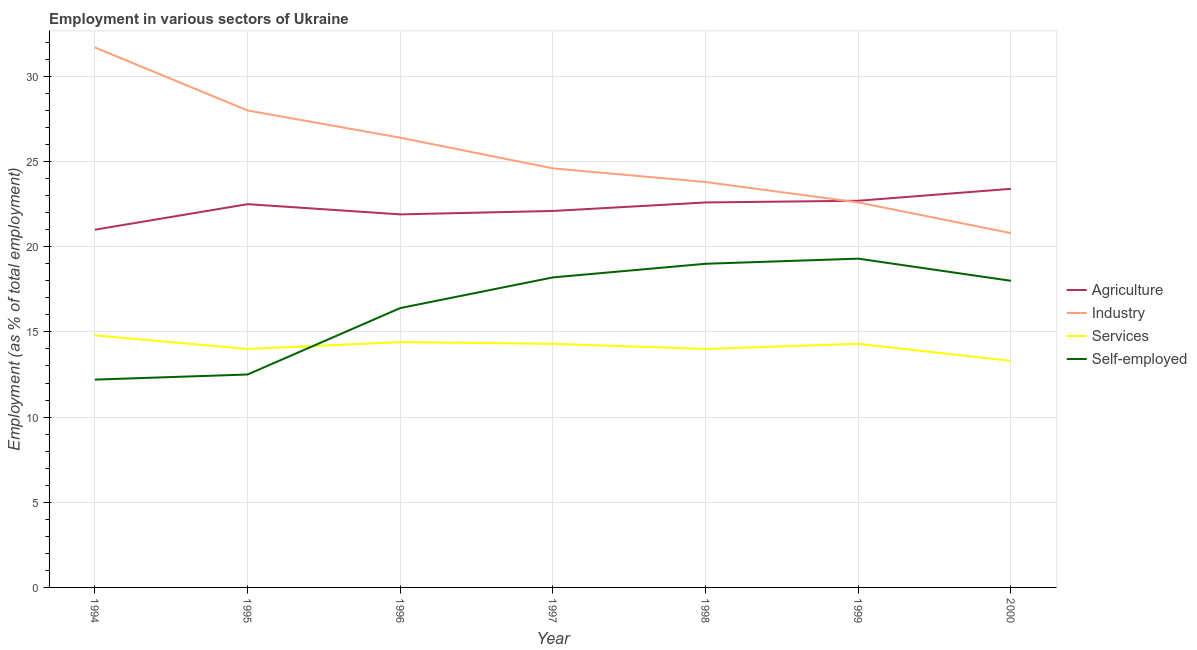Does the line corresponding to percentage of self employed workers intersect with the line corresponding to percentage of workers in industry?
Offer a terse response. No. Is the number of lines equal to the number of legend labels?
Provide a succinct answer. Yes. Across all years, what is the maximum percentage of self employed workers?
Your response must be concise. 19.3. Across all years, what is the minimum percentage of workers in services?
Your answer should be compact. 13.3. In which year was the percentage of self employed workers maximum?
Offer a terse response. 1999. In which year was the percentage of workers in agriculture minimum?
Make the answer very short. 1994. What is the total percentage of workers in industry in the graph?
Offer a very short reply. 177.9. What is the difference between the percentage of workers in services in 1994 and that in 1999?
Provide a succinct answer. 0.5. What is the difference between the percentage of workers in agriculture in 1997 and the percentage of workers in industry in 1994?
Make the answer very short. -9.6. What is the average percentage of workers in services per year?
Give a very brief answer. 14.16. In the year 1998, what is the difference between the percentage of workers in services and percentage of workers in industry?
Give a very brief answer. -9.8. In how many years, is the percentage of workers in agriculture greater than 17 %?
Your response must be concise. 7. What is the ratio of the percentage of workers in industry in 1994 to that in 1996?
Make the answer very short. 1.2. What is the difference between the highest and the second highest percentage of workers in agriculture?
Keep it short and to the point. 0.7. What is the difference between the highest and the lowest percentage of workers in industry?
Keep it short and to the point. 10.9. In how many years, is the percentage of workers in industry greater than the average percentage of workers in industry taken over all years?
Offer a very short reply. 3. How many lines are there?
Give a very brief answer. 4. What is the difference between two consecutive major ticks on the Y-axis?
Provide a succinct answer. 5. Does the graph contain grids?
Provide a succinct answer. Yes. How many legend labels are there?
Make the answer very short. 4. How are the legend labels stacked?
Offer a terse response. Vertical. What is the title of the graph?
Keep it short and to the point. Employment in various sectors of Ukraine. Does "Forest" appear as one of the legend labels in the graph?
Offer a terse response. No. What is the label or title of the X-axis?
Ensure brevity in your answer.  Year. What is the label or title of the Y-axis?
Offer a terse response. Employment (as % of total employment). What is the Employment (as % of total employment) in Agriculture in 1994?
Your answer should be compact. 21. What is the Employment (as % of total employment) in Industry in 1994?
Your response must be concise. 31.7. What is the Employment (as % of total employment) in Services in 1994?
Make the answer very short. 14.8. What is the Employment (as % of total employment) of Self-employed in 1994?
Keep it short and to the point. 12.2. What is the Employment (as % of total employment) in Agriculture in 1996?
Offer a very short reply. 21.9. What is the Employment (as % of total employment) of Industry in 1996?
Give a very brief answer. 26.4. What is the Employment (as % of total employment) in Services in 1996?
Your response must be concise. 14.4. What is the Employment (as % of total employment) of Self-employed in 1996?
Make the answer very short. 16.4. What is the Employment (as % of total employment) of Agriculture in 1997?
Your response must be concise. 22.1. What is the Employment (as % of total employment) of Industry in 1997?
Keep it short and to the point. 24.6. What is the Employment (as % of total employment) in Services in 1997?
Make the answer very short. 14.3. What is the Employment (as % of total employment) in Self-employed in 1997?
Your response must be concise. 18.2. What is the Employment (as % of total employment) of Agriculture in 1998?
Give a very brief answer. 22.6. What is the Employment (as % of total employment) in Industry in 1998?
Provide a short and direct response. 23.8. What is the Employment (as % of total employment) in Agriculture in 1999?
Your answer should be compact. 22.7. What is the Employment (as % of total employment) of Industry in 1999?
Provide a succinct answer. 22.6. What is the Employment (as % of total employment) in Services in 1999?
Give a very brief answer. 14.3. What is the Employment (as % of total employment) of Self-employed in 1999?
Make the answer very short. 19.3. What is the Employment (as % of total employment) in Agriculture in 2000?
Your answer should be very brief. 23.4. What is the Employment (as % of total employment) of Industry in 2000?
Your answer should be very brief. 20.8. What is the Employment (as % of total employment) in Services in 2000?
Your answer should be very brief. 13.3. Across all years, what is the maximum Employment (as % of total employment) of Agriculture?
Provide a short and direct response. 23.4. Across all years, what is the maximum Employment (as % of total employment) in Industry?
Ensure brevity in your answer.  31.7. Across all years, what is the maximum Employment (as % of total employment) of Services?
Ensure brevity in your answer.  14.8. Across all years, what is the maximum Employment (as % of total employment) in Self-employed?
Give a very brief answer. 19.3. Across all years, what is the minimum Employment (as % of total employment) of Agriculture?
Keep it short and to the point. 21. Across all years, what is the minimum Employment (as % of total employment) in Industry?
Give a very brief answer. 20.8. Across all years, what is the minimum Employment (as % of total employment) in Services?
Ensure brevity in your answer.  13.3. Across all years, what is the minimum Employment (as % of total employment) in Self-employed?
Give a very brief answer. 12.2. What is the total Employment (as % of total employment) in Agriculture in the graph?
Ensure brevity in your answer.  156.2. What is the total Employment (as % of total employment) of Industry in the graph?
Your answer should be compact. 177.9. What is the total Employment (as % of total employment) of Services in the graph?
Ensure brevity in your answer.  99.1. What is the total Employment (as % of total employment) of Self-employed in the graph?
Give a very brief answer. 115.6. What is the difference between the Employment (as % of total employment) of Agriculture in 1994 and that in 1995?
Offer a very short reply. -1.5. What is the difference between the Employment (as % of total employment) in Industry in 1994 and that in 1995?
Provide a short and direct response. 3.7. What is the difference between the Employment (as % of total employment) of Services in 1994 and that in 1995?
Your answer should be compact. 0.8. What is the difference between the Employment (as % of total employment) in Self-employed in 1994 and that in 1996?
Give a very brief answer. -4.2. What is the difference between the Employment (as % of total employment) of Agriculture in 1994 and that in 1997?
Provide a succinct answer. -1.1. What is the difference between the Employment (as % of total employment) in Services in 1994 and that in 1998?
Provide a succinct answer. 0.8. What is the difference between the Employment (as % of total employment) of Self-employed in 1994 and that in 1998?
Provide a short and direct response. -6.8. What is the difference between the Employment (as % of total employment) of Industry in 1994 and that in 1999?
Ensure brevity in your answer.  9.1. What is the difference between the Employment (as % of total employment) of Services in 1994 and that in 1999?
Make the answer very short. 0.5. What is the difference between the Employment (as % of total employment) of Self-employed in 1994 and that in 2000?
Offer a very short reply. -5.8. What is the difference between the Employment (as % of total employment) of Services in 1995 and that in 1996?
Your answer should be compact. -0.4. What is the difference between the Employment (as % of total employment) in Agriculture in 1995 and that in 1997?
Keep it short and to the point. 0.4. What is the difference between the Employment (as % of total employment) of Self-employed in 1995 and that in 1997?
Offer a terse response. -5.7. What is the difference between the Employment (as % of total employment) in Agriculture in 1995 and that in 1998?
Keep it short and to the point. -0.1. What is the difference between the Employment (as % of total employment) in Self-employed in 1995 and that in 1998?
Ensure brevity in your answer.  -6.5. What is the difference between the Employment (as % of total employment) of Industry in 1995 and that in 2000?
Make the answer very short. 7.2. What is the difference between the Employment (as % of total employment) of Services in 1995 and that in 2000?
Ensure brevity in your answer.  0.7. What is the difference between the Employment (as % of total employment) of Self-employed in 1995 and that in 2000?
Keep it short and to the point. -5.5. What is the difference between the Employment (as % of total employment) of Agriculture in 1996 and that in 1997?
Your response must be concise. -0.2. What is the difference between the Employment (as % of total employment) in Industry in 1996 and that in 1998?
Keep it short and to the point. 2.6. What is the difference between the Employment (as % of total employment) of Self-employed in 1996 and that in 1998?
Keep it short and to the point. -2.6. What is the difference between the Employment (as % of total employment) in Industry in 1996 and that in 1999?
Ensure brevity in your answer.  3.8. What is the difference between the Employment (as % of total employment) in Agriculture in 1996 and that in 2000?
Your answer should be very brief. -1.5. What is the difference between the Employment (as % of total employment) in Industry in 1996 and that in 2000?
Ensure brevity in your answer.  5.6. What is the difference between the Employment (as % of total employment) of Self-employed in 1996 and that in 2000?
Your response must be concise. -1.6. What is the difference between the Employment (as % of total employment) of Agriculture in 1997 and that in 1999?
Your answer should be compact. -0.6. What is the difference between the Employment (as % of total employment) of Industry in 1997 and that in 1999?
Offer a terse response. 2. What is the difference between the Employment (as % of total employment) of Services in 1997 and that in 1999?
Give a very brief answer. 0. What is the difference between the Employment (as % of total employment) of Self-employed in 1997 and that in 1999?
Give a very brief answer. -1.1. What is the difference between the Employment (as % of total employment) in Services in 1997 and that in 2000?
Make the answer very short. 1. What is the difference between the Employment (as % of total employment) in Self-employed in 1997 and that in 2000?
Make the answer very short. 0.2. What is the difference between the Employment (as % of total employment) of Agriculture in 1998 and that in 1999?
Your response must be concise. -0.1. What is the difference between the Employment (as % of total employment) of Industry in 1998 and that in 1999?
Your answer should be compact. 1.2. What is the difference between the Employment (as % of total employment) in Services in 1998 and that in 1999?
Offer a very short reply. -0.3. What is the difference between the Employment (as % of total employment) of Self-employed in 1998 and that in 1999?
Your answer should be very brief. -0.3. What is the difference between the Employment (as % of total employment) in Agriculture in 1998 and that in 2000?
Your answer should be very brief. -0.8. What is the difference between the Employment (as % of total employment) of Industry in 1998 and that in 2000?
Your answer should be compact. 3. What is the difference between the Employment (as % of total employment) in Services in 1998 and that in 2000?
Offer a terse response. 0.7. What is the difference between the Employment (as % of total employment) in Agriculture in 1999 and that in 2000?
Provide a short and direct response. -0.7. What is the difference between the Employment (as % of total employment) of Services in 1999 and that in 2000?
Provide a succinct answer. 1. What is the difference between the Employment (as % of total employment) in Agriculture in 1994 and the Employment (as % of total employment) in Self-employed in 1995?
Provide a short and direct response. 8.5. What is the difference between the Employment (as % of total employment) of Industry in 1994 and the Employment (as % of total employment) of Self-employed in 1995?
Your response must be concise. 19.2. What is the difference between the Employment (as % of total employment) in Services in 1994 and the Employment (as % of total employment) in Self-employed in 1995?
Your response must be concise. 2.3. What is the difference between the Employment (as % of total employment) of Agriculture in 1994 and the Employment (as % of total employment) of Industry in 1996?
Your response must be concise. -5.4. What is the difference between the Employment (as % of total employment) in Agriculture in 1994 and the Employment (as % of total employment) in Services in 1996?
Your response must be concise. 6.6. What is the difference between the Employment (as % of total employment) in Agriculture in 1994 and the Employment (as % of total employment) in Self-employed in 1996?
Provide a short and direct response. 4.6. What is the difference between the Employment (as % of total employment) of Industry in 1994 and the Employment (as % of total employment) of Services in 1996?
Provide a succinct answer. 17.3. What is the difference between the Employment (as % of total employment) in Industry in 1994 and the Employment (as % of total employment) in Self-employed in 1996?
Your answer should be very brief. 15.3. What is the difference between the Employment (as % of total employment) of Services in 1994 and the Employment (as % of total employment) of Self-employed in 1996?
Ensure brevity in your answer.  -1.6. What is the difference between the Employment (as % of total employment) in Agriculture in 1994 and the Employment (as % of total employment) in Self-employed in 1997?
Make the answer very short. 2.8. What is the difference between the Employment (as % of total employment) in Agriculture in 1994 and the Employment (as % of total employment) in Services in 1998?
Give a very brief answer. 7. What is the difference between the Employment (as % of total employment) in Industry in 1994 and the Employment (as % of total employment) in Self-employed in 1998?
Provide a short and direct response. 12.7. What is the difference between the Employment (as % of total employment) of Agriculture in 1994 and the Employment (as % of total employment) of Industry in 1999?
Ensure brevity in your answer.  -1.6. What is the difference between the Employment (as % of total employment) of Services in 1994 and the Employment (as % of total employment) of Self-employed in 1999?
Offer a very short reply. -4.5. What is the difference between the Employment (as % of total employment) in Agriculture in 1994 and the Employment (as % of total employment) in Industry in 2000?
Offer a very short reply. 0.2. What is the difference between the Employment (as % of total employment) of Industry in 1994 and the Employment (as % of total employment) of Services in 2000?
Keep it short and to the point. 18.4. What is the difference between the Employment (as % of total employment) in Industry in 1994 and the Employment (as % of total employment) in Self-employed in 2000?
Your answer should be very brief. 13.7. What is the difference between the Employment (as % of total employment) of Services in 1994 and the Employment (as % of total employment) of Self-employed in 2000?
Your answer should be very brief. -3.2. What is the difference between the Employment (as % of total employment) of Agriculture in 1995 and the Employment (as % of total employment) of Industry in 1996?
Your answer should be compact. -3.9. What is the difference between the Employment (as % of total employment) of Agriculture in 1995 and the Employment (as % of total employment) of Services in 1996?
Keep it short and to the point. 8.1. What is the difference between the Employment (as % of total employment) in Agriculture in 1995 and the Employment (as % of total employment) in Self-employed in 1996?
Provide a succinct answer. 6.1. What is the difference between the Employment (as % of total employment) in Industry in 1995 and the Employment (as % of total employment) in Self-employed in 1996?
Give a very brief answer. 11.6. What is the difference between the Employment (as % of total employment) of Agriculture in 1995 and the Employment (as % of total employment) of Industry in 1997?
Your answer should be compact. -2.1. What is the difference between the Employment (as % of total employment) of Agriculture in 1995 and the Employment (as % of total employment) of Self-employed in 1997?
Provide a short and direct response. 4.3. What is the difference between the Employment (as % of total employment) in Industry in 1995 and the Employment (as % of total employment) in Self-employed in 1997?
Provide a succinct answer. 9.8. What is the difference between the Employment (as % of total employment) of Industry in 1995 and the Employment (as % of total employment) of Services in 1998?
Your answer should be compact. 14. What is the difference between the Employment (as % of total employment) of Industry in 1995 and the Employment (as % of total employment) of Self-employed in 1998?
Provide a short and direct response. 9. What is the difference between the Employment (as % of total employment) of Services in 1995 and the Employment (as % of total employment) of Self-employed in 1998?
Offer a very short reply. -5. What is the difference between the Employment (as % of total employment) of Services in 1995 and the Employment (as % of total employment) of Self-employed in 1999?
Keep it short and to the point. -5.3. What is the difference between the Employment (as % of total employment) of Agriculture in 1995 and the Employment (as % of total employment) of Services in 2000?
Offer a very short reply. 9.2. What is the difference between the Employment (as % of total employment) of Industry in 1995 and the Employment (as % of total employment) of Services in 2000?
Provide a succinct answer. 14.7. What is the difference between the Employment (as % of total employment) in Industry in 1995 and the Employment (as % of total employment) in Self-employed in 2000?
Ensure brevity in your answer.  10. What is the difference between the Employment (as % of total employment) of Agriculture in 1996 and the Employment (as % of total employment) of Services in 1997?
Keep it short and to the point. 7.6. What is the difference between the Employment (as % of total employment) of Agriculture in 1996 and the Employment (as % of total employment) of Industry in 1998?
Your answer should be compact. -1.9. What is the difference between the Employment (as % of total employment) in Industry in 1996 and the Employment (as % of total employment) in Services in 1998?
Give a very brief answer. 12.4. What is the difference between the Employment (as % of total employment) of Industry in 1996 and the Employment (as % of total employment) of Self-employed in 1998?
Offer a very short reply. 7.4. What is the difference between the Employment (as % of total employment) of Agriculture in 1996 and the Employment (as % of total employment) of Industry in 1999?
Make the answer very short. -0.7. What is the difference between the Employment (as % of total employment) of Agriculture in 1996 and the Employment (as % of total employment) of Services in 1999?
Keep it short and to the point. 7.6. What is the difference between the Employment (as % of total employment) in Agriculture in 1996 and the Employment (as % of total employment) in Self-employed in 1999?
Offer a very short reply. 2.6. What is the difference between the Employment (as % of total employment) of Industry in 1996 and the Employment (as % of total employment) of Services in 1999?
Offer a terse response. 12.1. What is the difference between the Employment (as % of total employment) of Agriculture in 1996 and the Employment (as % of total employment) of Industry in 2000?
Provide a short and direct response. 1.1. What is the difference between the Employment (as % of total employment) of Agriculture in 1996 and the Employment (as % of total employment) of Services in 2000?
Give a very brief answer. 8.6. What is the difference between the Employment (as % of total employment) of Agriculture in 1996 and the Employment (as % of total employment) of Self-employed in 2000?
Provide a short and direct response. 3.9. What is the difference between the Employment (as % of total employment) of Agriculture in 1997 and the Employment (as % of total employment) of Services in 1998?
Provide a short and direct response. 8.1. What is the difference between the Employment (as % of total employment) of Agriculture in 1997 and the Employment (as % of total employment) of Self-employed in 1998?
Your response must be concise. 3.1. What is the difference between the Employment (as % of total employment) in Industry in 1997 and the Employment (as % of total employment) in Services in 1998?
Your response must be concise. 10.6. What is the difference between the Employment (as % of total employment) in Services in 1997 and the Employment (as % of total employment) in Self-employed in 1998?
Your answer should be compact. -4.7. What is the difference between the Employment (as % of total employment) of Agriculture in 1997 and the Employment (as % of total employment) of Industry in 1999?
Provide a succinct answer. -0.5. What is the difference between the Employment (as % of total employment) in Services in 1997 and the Employment (as % of total employment) in Self-employed in 1999?
Offer a very short reply. -5. What is the difference between the Employment (as % of total employment) of Agriculture in 1997 and the Employment (as % of total employment) of Industry in 2000?
Ensure brevity in your answer.  1.3. What is the difference between the Employment (as % of total employment) in Agriculture in 1997 and the Employment (as % of total employment) in Self-employed in 2000?
Provide a succinct answer. 4.1. What is the difference between the Employment (as % of total employment) in Services in 1997 and the Employment (as % of total employment) in Self-employed in 2000?
Your response must be concise. -3.7. What is the difference between the Employment (as % of total employment) in Agriculture in 1998 and the Employment (as % of total employment) in Self-employed in 1999?
Ensure brevity in your answer.  3.3. What is the difference between the Employment (as % of total employment) in Industry in 1998 and the Employment (as % of total employment) in Self-employed in 1999?
Your answer should be compact. 4.5. What is the difference between the Employment (as % of total employment) in Agriculture in 1998 and the Employment (as % of total employment) in Industry in 2000?
Ensure brevity in your answer.  1.8. What is the difference between the Employment (as % of total employment) of Agriculture in 1998 and the Employment (as % of total employment) of Self-employed in 2000?
Your answer should be compact. 4.6. What is the difference between the Employment (as % of total employment) of Industry in 1998 and the Employment (as % of total employment) of Services in 2000?
Ensure brevity in your answer.  10.5. What is the difference between the Employment (as % of total employment) in Industry in 1999 and the Employment (as % of total employment) in Services in 2000?
Your answer should be very brief. 9.3. What is the difference between the Employment (as % of total employment) of Industry in 1999 and the Employment (as % of total employment) of Self-employed in 2000?
Provide a short and direct response. 4.6. What is the difference between the Employment (as % of total employment) in Services in 1999 and the Employment (as % of total employment) in Self-employed in 2000?
Offer a very short reply. -3.7. What is the average Employment (as % of total employment) of Agriculture per year?
Make the answer very short. 22.31. What is the average Employment (as % of total employment) in Industry per year?
Your answer should be compact. 25.41. What is the average Employment (as % of total employment) in Services per year?
Your response must be concise. 14.16. What is the average Employment (as % of total employment) in Self-employed per year?
Your answer should be very brief. 16.51. In the year 1994, what is the difference between the Employment (as % of total employment) in Agriculture and Employment (as % of total employment) in Industry?
Offer a terse response. -10.7. In the year 1994, what is the difference between the Employment (as % of total employment) of Industry and Employment (as % of total employment) of Self-employed?
Offer a terse response. 19.5. In the year 1995, what is the difference between the Employment (as % of total employment) of Industry and Employment (as % of total employment) of Services?
Provide a succinct answer. 14. In the year 1995, what is the difference between the Employment (as % of total employment) in Services and Employment (as % of total employment) in Self-employed?
Give a very brief answer. 1.5. In the year 1996, what is the difference between the Employment (as % of total employment) of Agriculture and Employment (as % of total employment) of Industry?
Your answer should be very brief. -4.5. In the year 1997, what is the difference between the Employment (as % of total employment) of Agriculture and Employment (as % of total employment) of Industry?
Give a very brief answer. -2.5. In the year 1997, what is the difference between the Employment (as % of total employment) in Agriculture and Employment (as % of total employment) in Services?
Offer a terse response. 7.8. In the year 1997, what is the difference between the Employment (as % of total employment) of Agriculture and Employment (as % of total employment) of Self-employed?
Your answer should be compact. 3.9. In the year 1997, what is the difference between the Employment (as % of total employment) of Industry and Employment (as % of total employment) of Services?
Give a very brief answer. 10.3. In the year 1998, what is the difference between the Employment (as % of total employment) in Agriculture and Employment (as % of total employment) in Services?
Your response must be concise. 8.6. In the year 1998, what is the difference between the Employment (as % of total employment) in Industry and Employment (as % of total employment) in Services?
Your response must be concise. 9.8. In the year 1998, what is the difference between the Employment (as % of total employment) of Industry and Employment (as % of total employment) of Self-employed?
Make the answer very short. 4.8. In the year 1998, what is the difference between the Employment (as % of total employment) in Services and Employment (as % of total employment) in Self-employed?
Your answer should be compact. -5. In the year 1999, what is the difference between the Employment (as % of total employment) in Industry and Employment (as % of total employment) in Self-employed?
Provide a short and direct response. 3.3. In the year 1999, what is the difference between the Employment (as % of total employment) of Services and Employment (as % of total employment) of Self-employed?
Provide a short and direct response. -5. In the year 2000, what is the difference between the Employment (as % of total employment) in Agriculture and Employment (as % of total employment) in Industry?
Your response must be concise. 2.6. In the year 2000, what is the difference between the Employment (as % of total employment) of Agriculture and Employment (as % of total employment) of Services?
Provide a succinct answer. 10.1. In the year 2000, what is the difference between the Employment (as % of total employment) in Agriculture and Employment (as % of total employment) in Self-employed?
Offer a terse response. 5.4. In the year 2000, what is the difference between the Employment (as % of total employment) in Industry and Employment (as % of total employment) in Services?
Provide a short and direct response. 7.5. In the year 2000, what is the difference between the Employment (as % of total employment) in Services and Employment (as % of total employment) in Self-employed?
Provide a short and direct response. -4.7. What is the ratio of the Employment (as % of total employment) of Industry in 1994 to that in 1995?
Your answer should be compact. 1.13. What is the ratio of the Employment (as % of total employment) of Services in 1994 to that in 1995?
Offer a very short reply. 1.06. What is the ratio of the Employment (as % of total employment) in Agriculture in 1994 to that in 1996?
Offer a terse response. 0.96. What is the ratio of the Employment (as % of total employment) of Industry in 1994 to that in 1996?
Provide a short and direct response. 1.2. What is the ratio of the Employment (as % of total employment) of Services in 1994 to that in 1996?
Your answer should be compact. 1.03. What is the ratio of the Employment (as % of total employment) in Self-employed in 1994 to that in 1996?
Provide a short and direct response. 0.74. What is the ratio of the Employment (as % of total employment) of Agriculture in 1994 to that in 1997?
Provide a succinct answer. 0.95. What is the ratio of the Employment (as % of total employment) of Industry in 1994 to that in 1997?
Your answer should be compact. 1.29. What is the ratio of the Employment (as % of total employment) of Services in 1994 to that in 1997?
Your response must be concise. 1.03. What is the ratio of the Employment (as % of total employment) in Self-employed in 1994 to that in 1997?
Your response must be concise. 0.67. What is the ratio of the Employment (as % of total employment) in Agriculture in 1994 to that in 1998?
Make the answer very short. 0.93. What is the ratio of the Employment (as % of total employment) in Industry in 1994 to that in 1998?
Offer a very short reply. 1.33. What is the ratio of the Employment (as % of total employment) in Services in 1994 to that in 1998?
Your answer should be very brief. 1.06. What is the ratio of the Employment (as % of total employment) of Self-employed in 1994 to that in 1998?
Your answer should be compact. 0.64. What is the ratio of the Employment (as % of total employment) of Agriculture in 1994 to that in 1999?
Ensure brevity in your answer.  0.93. What is the ratio of the Employment (as % of total employment) of Industry in 1994 to that in 1999?
Offer a terse response. 1.4. What is the ratio of the Employment (as % of total employment) of Services in 1994 to that in 1999?
Make the answer very short. 1.03. What is the ratio of the Employment (as % of total employment) of Self-employed in 1994 to that in 1999?
Your answer should be compact. 0.63. What is the ratio of the Employment (as % of total employment) in Agriculture in 1994 to that in 2000?
Provide a short and direct response. 0.9. What is the ratio of the Employment (as % of total employment) in Industry in 1994 to that in 2000?
Provide a succinct answer. 1.52. What is the ratio of the Employment (as % of total employment) in Services in 1994 to that in 2000?
Your answer should be very brief. 1.11. What is the ratio of the Employment (as % of total employment) of Self-employed in 1994 to that in 2000?
Your response must be concise. 0.68. What is the ratio of the Employment (as % of total employment) of Agriculture in 1995 to that in 1996?
Keep it short and to the point. 1.03. What is the ratio of the Employment (as % of total employment) of Industry in 1995 to that in 1996?
Your answer should be compact. 1.06. What is the ratio of the Employment (as % of total employment) in Services in 1995 to that in 1996?
Offer a very short reply. 0.97. What is the ratio of the Employment (as % of total employment) in Self-employed in 1995 to that in 1996?
Provide a short and direct response. 0.76. What is the ratio of the Employment (as % of total employment) in Agriculture in 1995 to that in 1997?
Keep it short and to the point. 1.02. What is the ratio of the Employment (as % of total employment) in Industry in 1995 to that in 1997?
Provide a succinct answer. 1.14. What is the ratio of the Employment (as % of total employment) of Services in 1995 to that in 1997?
Ensure brevity in your answer.  0.98. What is the ratio of the Employment (as % of total employment) of Self-employed in 1995 to that in 1997?
Offer a terse response. 0.69. What is the ratio of the Employment (as % of total employment) of Industry in 1995 to that in 1998?
Offer a very short reply. 1.18. What is the ratio of the Employment (as % of total employment) of Self-employed in 1995 to that in 1998?
Offer a terse response. 0.66. What is the ratio of the Employment (as % of total employment) in Industry in 1995 to that in 1999?
Offer a very short reply. 1.24. What is the ratio of the Employment (as % of total employment) in Services in 1995 to that in 1999?
Provide a short and direct response. 0.98. What is the ratio of the Employment (as % of total employment) of Self-employed in 1995 to that in 1999?
Offer a very short reply. 0.65. What is the ratio of the Employment (as % of total employment) in Agriculture in 1995 to that in 2000?
Keep it short and to the point. 0.96. What is the ratio of the Employment (as % of total employment) of Industry in 1995 to that in 2000?
Give a very brief answer. 1.35. What is the ratio of the Employment (as % of total employment) of Services in 1995 to that in 2000?
Keep it short and to the point. 1.05. What is the ratio of the Employment (as % of total employment) in Self-employed in 1995 to that in 2000?
Your answer should be very brief. 0.69. What is the ratio of the Employment (as % of total employment) of Industry in 1996 to that in 1997?
Ensure brevity in your answer.  1.07. What is the ratio of the Employment (as % of total employment) in Services in 1996 to that in 1997?
Make the answer very short. 1.01. What is the ratio of the Employment (as % of total employment) in Self-employed in 1996 to that in 1997?
Make the answer very short. 0.9. What is the ratio of the Employment (as % of total employment) in Industry in 1996 to that in 1998?
Offer a terse response. 1.11. What is the ratio of the Employment (as % of total employment) in Services in 1996 to that in 1998?
Provide a short and direct response. 1.03. What is the ratio of the Employment (as % of total employment) in Self-employed in 1996 to that in 1998?
Offer a very short reply. 0.86. What is the ratio of the Employment (as % of total employment) in Agriculture in 1996 to that in 1999?
Your answer should be compact. 0.96. What is the ratio of the Employment (as % of total employment) of Industry in 1996 to that in 1999?
Keep it short and to the point. 1.17. What is the ratio of the Employment (as % of total employment) of Services in 1996 to that in 1999?
Offer a terse response. 1.01. What is the ratio of the Employment (as % of total employment) of Self-employed in 1996 to that in 1999?
Keep it short and to the point. 0.85. What is the ratio of the Employment (as % of total employment) in Agriculture in 1996 to that in 2000?
Provide a short and direct response. 0.94. What is the ratio of the Employment (as % of total employment) of Industry in 1996 to that in 2000?
Your answer should be compact. 1.27. What is the ratio of the Employment (as % of total employment) in Services in 1996 to that in 2000?
Offer a terse response. 1.08. What is the ratio of the Employment (as % of total employment) in Self-employed in 1996 to that in 2000?
Your answer should be compact. 0.91. What is the ratio of the Employment (as % of total employment) in Agriculture in 1997 to that in 1998?
Provide a short and direct response. 0.98. What is the ratio of the Employment (as % of total employment) of Industry in 1997 to that in 1998?
Keep it short and to the point. 1.03. What is the ratio of the Employment (as % of total employment) in Services in 1997 to that in 1998?
Make the answer very short. 1.02. What is the ratio of the Employment (as % of total employment) in Self-employed in 1997 to that in 1998?
Provide a succinct answer. 0.96. What is the ratio of the Employment (as % of total employment) in Agriculture in 1997 to that in 1999?
Keep it short and to the point. 0.97. What is the ratio of the Employment (as % of total employment) of Industry in 1997 to that in 1999?
Give a very brief answer. 1.09. What is the ratio of the Employment (as % of total employment) in Self-employed in 1997 to that in 1999?
Ensure brevity in your answer.  0.94. What is the ratio of the Employment (as % of total employment) of Agriculture in 1997 to that in 2000?
Your response must be concise. 0.94. What is the ratio of the Employment (as % of total employment) of Industry in 1997 to that in 2000?
Ensure brevity in your answer.  1.18. What is the ratio of the Employment (as % of total employment) in Services in 1997 to that in 2000?
Provide a short and direct response. 1.08. What is the ratio of the Employment (as % of total employment) of Self-employed in 1997 to that in 2000?
Keep it short and to the point. 1.01. What is the ratio of the Employment (as % of total employment) of Industry in 1998 to that in 1999?
Provide a succinct answer. 1.05. What is the ratio of the Employment (as % of total employment) in Services in 1998 to that in 1999?
Give a very brief answer. 0.98. What is the ratio of the Employment (as % of total employment) of Self-employed in 1998 to that in 1999?
Make the answer very short. 0.98. What is the ratio of the Employment (as % of total employment) in Agriculture in 1998 to that in 2000?
Give a very brief answer. 0.97. What is the ratio of the Employment (as % of total employment) in Industry in 1998 to that in 2000?
Give a very brief answer. 1.14. What is the ratio of the Employment (as % of total employment) in Services in 1998 to that in 2000?
Offer a terse response. 1.05. What is the ratio of the Employment (as % of total employment) of Self-employed in 1998 to that in 2000?
Offer a very short reply. 1.06. What is the ratio of the Employment (as % of total employment) in Agriculture in 1999 to that in 2000?
Give a very brief answer. 0.97. What is the ratio of the Employment (as % of total employment) in Industry in 1999 to that in 2000?
Ensure brevity in your answer.  1.09. What is the ratio of the Employment (as % of total employment) of Services in 1999 to that in 2000?
Give a very brief answer. 1.08. What is the ratio of the Employment (as % of total employment) in Self-employed in 1999 to that in 2000?
Ensure brevity in your answer.  1.07. What is the difference between the highest and the second highest Employment (as % of total employment) in Agriculture?
Keep it short and to the point. 0.7. What is the difference between the highest and the second highest Employment (as % of total employment) of Self-employed?
Your answer should be very brief. 0.3. What is the difference between the highest and the lowest Employment (as % of total employment) of Agriculture?
Provide a short and direct response. 2.4. What is the difference between the highest and the lowest Employment (as % of total employment) in Services?
Ensure brevity in your answer.  1.5. 